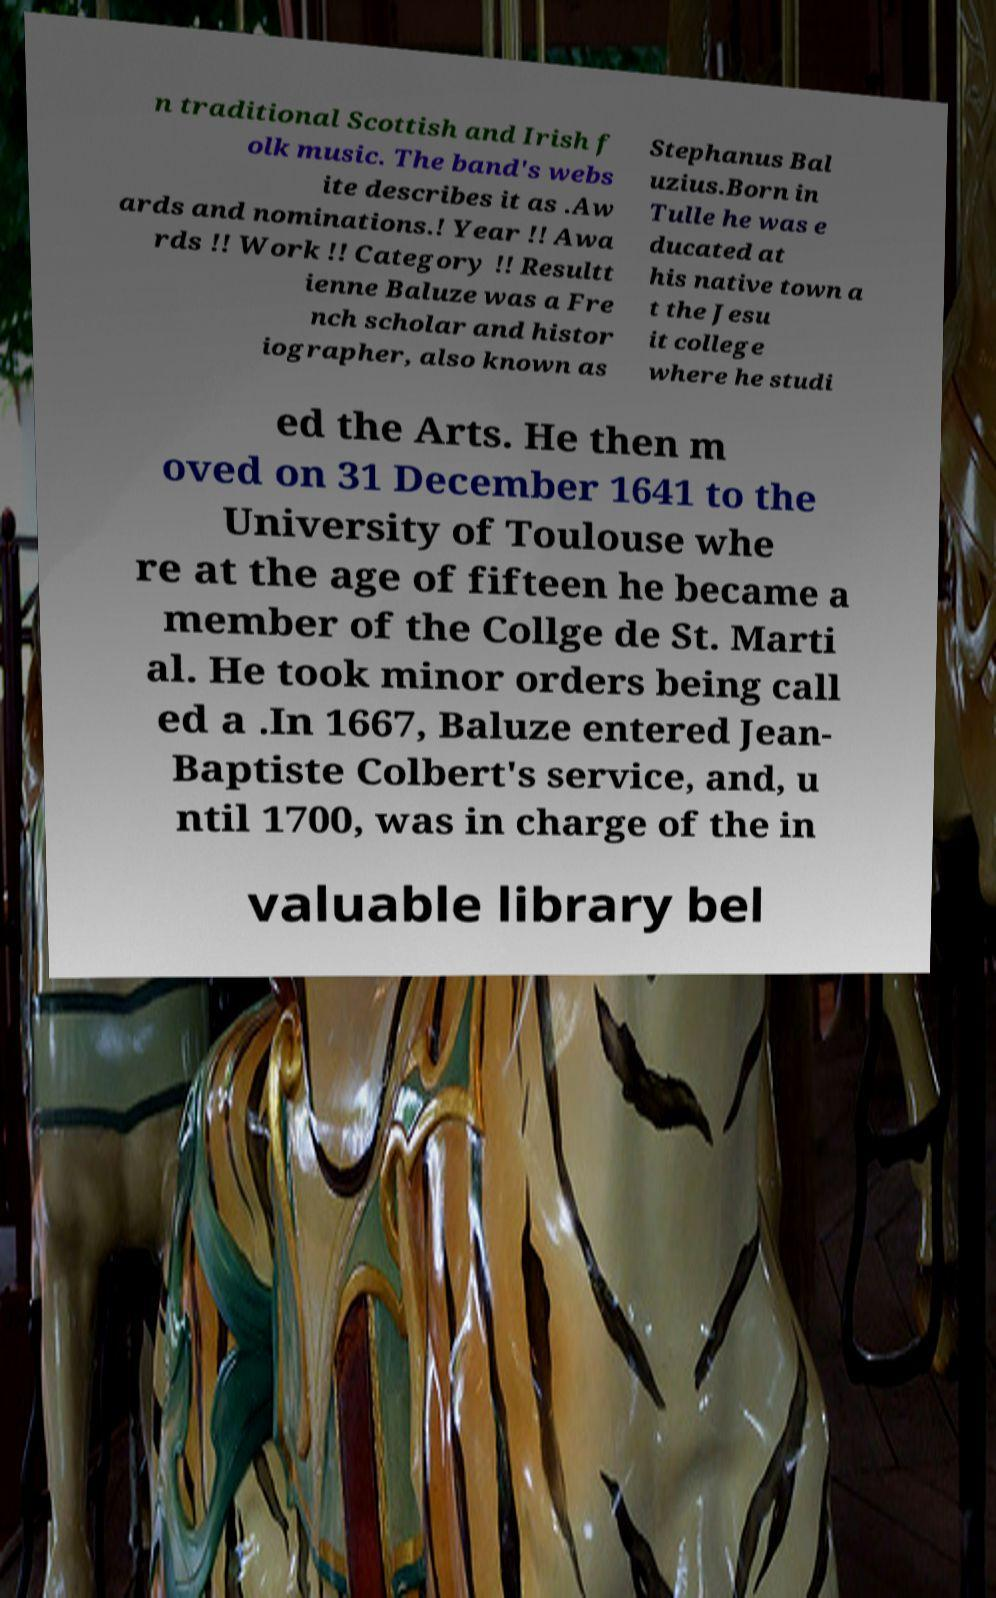What messages or text are displayed in this image? I need them in a readable, typed format. n traditional Scottish and Irish f olk music. The band's webs ite describes it as .Aw ards and nominations.! Year !! Awa rds !! Work !! Category !! Resultt ienne Baluze was a Fre nch scholar and histor iographer, also known as Stephanus Bal uzius.Born in Tulle he was e ducated at his native town a t the Jesu it college where he studi ed the Arts. He then m oved on 31 December 1641 to the University of Toulouse whe re at the age of fifteen he became a member of the Collge de St. Marti al. He took minor orders being call ed a .In 1667, Baluze entered Jean- Baptiste Colbert's service, and, u ntil 1700, was in charge of the in valuable library bel 